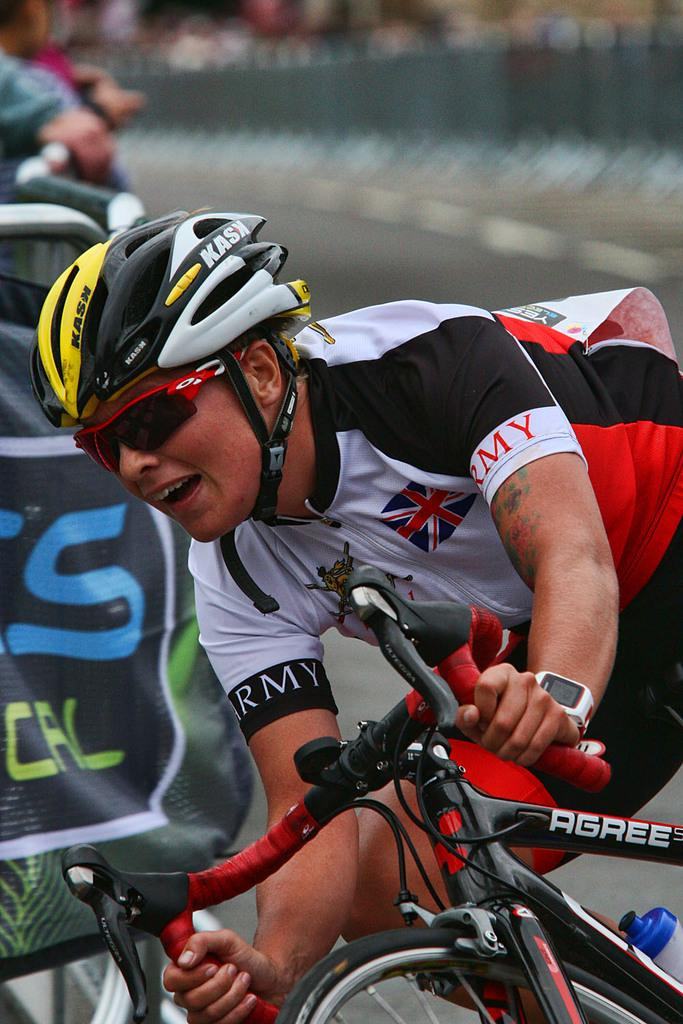What is the main subject of the image? There is a man in the image. What is the man doing in the image? The man is riding a bicycle. How many divisions can be seen in the image? There is no division present in the image; it features a man riding a bicycle. What type of material is the man rubbing against in the image? There is no rubbing or specific material mentioned in the image; it only shows a man riding a bicycle. 